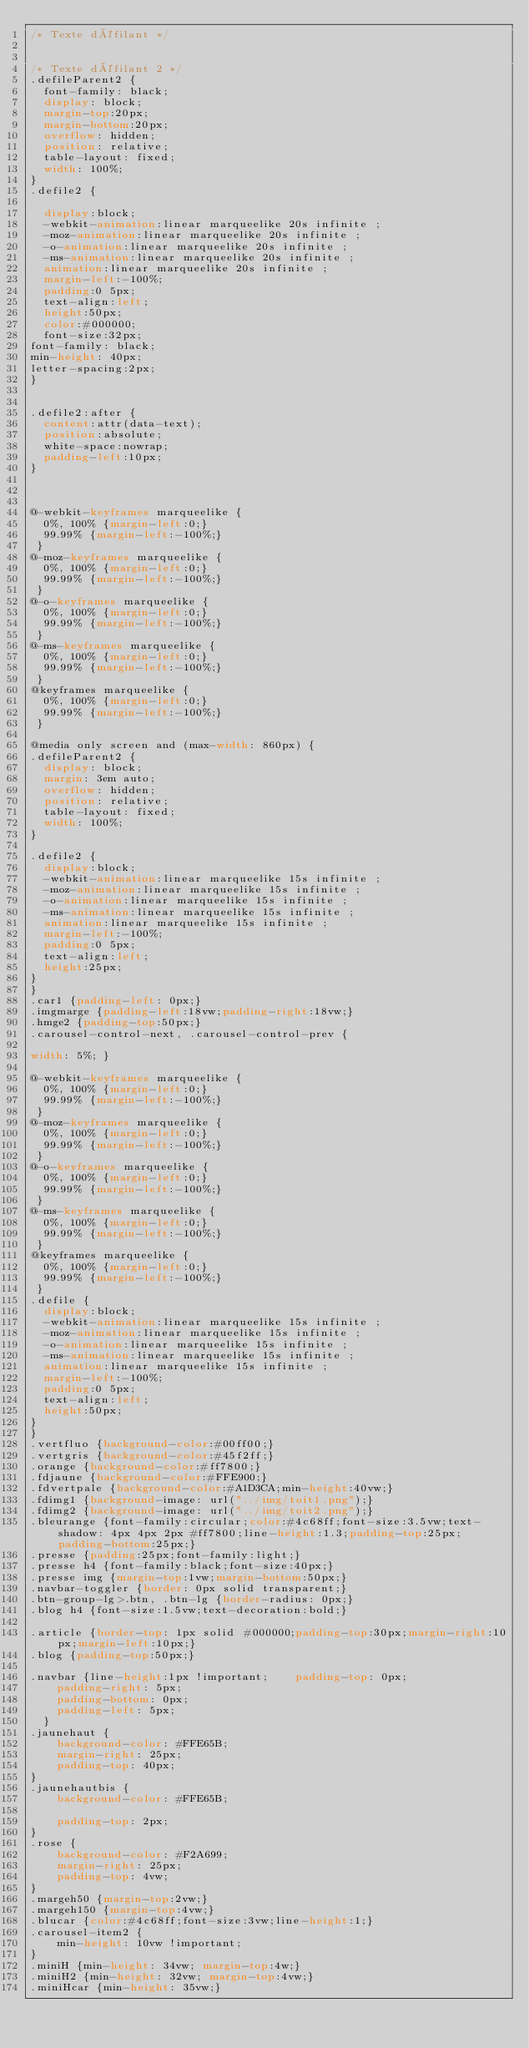Convert code to text. <code><loc_0><loc_0><loc_500><loc_500><_CSS_>/* Texte défilant */


/* Texte défilant 2 */
.defileParent2 {
	font-family: black;
	display: block;
	margin-top:20px;
	margin-bottom:20px;
	overflow: hidden;
	position: relative;
	table-layout: fixed;
	width: 100%;
}
.defile2 {
	
	display:block;
	-webkit-animation:linear marqueelike 20s infinite ;
	-moz-animation:linear marqueelike 20s infinite ;
	-o-animation:linear marqueelike 20s infinite ;
	-ms-animation:linear marqueelike 20s infinite ;
	animation:linear marqueelike 20s infinite ;
	margin-left:-100%;
	padding:0 5px;
	text-align:left;
	height:50px;
	color:#000000;
	font-size:32px;
font-family: black;
min-height: 40px;
letter-spacing:2px;
}


.defile2:after {
	content:attr(data-text);
	position:absolute;
	white-space:nowrap;
	padding-left:10px;
}



@-webkit-keyframes marqueelike {
	0%, 100% {margin-left:0;}
	99.99% {margin-left:-100%;}
 }
@-moz-keyframes marqueelike {
	0%, 100% {margin-left:0;}
	99.99% {margin-left:-100%;}
 }
@-o-keyframes marqueelike {
	0%, 100% {margin-left:0;}
	99.99% {margin-left:-100%;}
 }
@-ms-keyframes marqueelike {
	0%, 100% {margin-left:0;}
	99.99% {margin-left:-100%;}
 }
@keyframes marqueelike {
	0%, 100% {margin-left:0;}
	99.99% {margin-left:-100%;}
 }

@media only screen and (max-width: 860px) {
.defileParent2 {
	display: block;
	margin: 3em auto;
	overflow: hidden;
	position: relative;
	table-layout: fixed;
	width: 100%;
}

.defile2 {
	display:block;
	-webkit-animation:linear marqueelike 15s infinite ;
	-moz-animation:linear marqueelike 15s infinite ;
	-o-animation:linear marqueelike 15s infinite ;
	-ms-animation:linear marqueelike 15s infinite ;
	animation:linear marqueelike 15s infinite ;
	margin-left:-100%;
	padding:0 5px;
	text-align:left;
	height:25px;
}
}
.car1 {padding-left: 0px;}
.imgmarge {padding-left:18vw;padding-right:18vw;}
.hmge2 {padding-top:50px;}
.carousel-control-next, .carousel-control-prev {

width: 5%; }

@-webkit-keyframes marqueelike {
	0%, 100% {margin-left:0;}
	99.99% {margin-left:-100%;}
 }
@-moz-keyframes marqueelike {
	0%, 100% {margin-left:0;}
	99.99% {margin-left:-100%;}
 }
@-o-keyframes marqueelike {
	0%, 100% {margin-left:0;}
	99.99% {margin-left:-100%;}
 }
@-ms-keyframes marqueelike {
	0%, 100% {margin-left:0;}
	99.99% {margin-left:-100%;}
 }
@keyframes marqueelike {
	0%, 100% {margin-left:0;}
	99.99% {margin-left:-100%;}
 }
.defile {
	display:block;
	-webkit-animation:linear marqueelike 15s infinite ;
	-moz-animation:linear marqueelike 15s infinite ;
	-o-animation:linear marqueelike 15s infinite ;
	-ms-animation:linear marqueelike 15s infinite ;
	animation:linear marqueelike 15s infinite ;
	margin-left:-100%;
	padding:0 5px;
	text-align:left;
	height:50px;
}
}
.vertfluo {background-color:#00ff00;}
.vertgris {background-color:#45f2ff;}
.orange {background-color:#ff7800;}
.fdjaune {background-color:#FFE900;}
.fdvertpale {background-color:#A1D3CA;min-height:40vw;}
.fdimg1 {background-image: url("../img/toit1.png");}
.fdimg2 {background-image: url("../img/toit2.png");}
.bleurange {font-family:circular;color:#4c68ff;font-size:3.5vw;text-shadow: 4px 4px 2px #ff7800;line-height:1.3;padding-top:25px;padding-bottom:25px;}
.presse {padding:25px;font-family:light;}
.presse h4 {font-family:black;font-size:40px;}
.presse img {margin-top:1vw;margin-bottom:50px;}
.navbar-toggler {border: 0px solid transparent;}
.btn-group-lg>.btn, .btn-lg {border-radius: 0px;}
.blog h4 {font-size:1.5vw;text-decoration:bold;}

.article {border-top: 1px solid #000000;padding-top:30px;margin-right:10px;margin-left:10px;}
.blog {padding-top:50px;}

.navbar {line-height:1px !important;    padding-top: 0px;
    padding-right: 5px;
    padding-bottom: 0px;
    padding-left: 5px;
	}
.jaunehaut {
    background-color: #FFE65B;
    margin-right: 25px;
    padding-top: 40px;
}
.jaunehautbis {
    background-color: #FFE65B;
  
    padding-top: 2px;
}
.rose {
    background-color: #F2A699;
    margin-right: 25px;
    padding-top: 4vw;
}
.margeh50 {margin-top:2vw;}
.margeh150 {margin-top:4vw;}
.blucar {color:#4c68ff;font-size:3vw;line-height:1;}
.carousel-item2 {
    min-height: 10vw !important;
}
.miniH {min-height: 34vw; margin-top:4w;}
.miniH2 {min-height: 32vw; margin-top:4vw;}
.miniHcar {min-height: 35vw;}</code> 